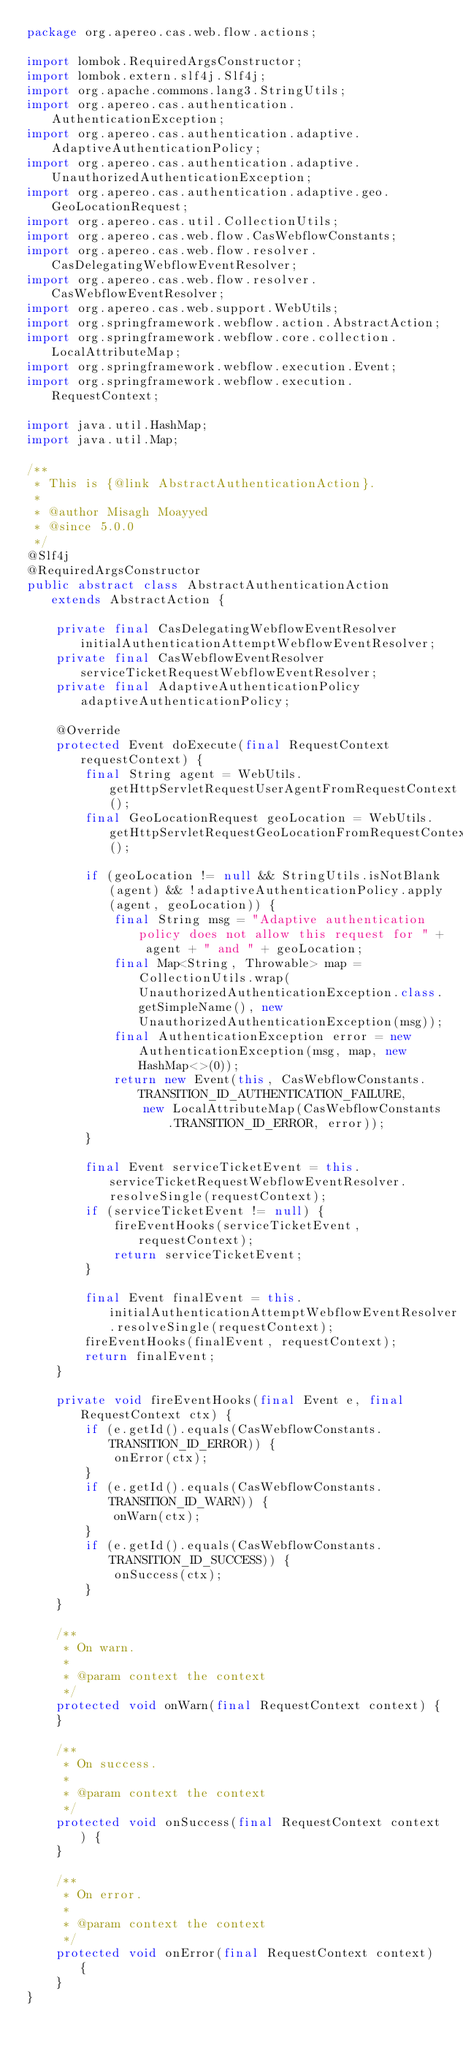Convert code to text. <code><loc_0><loc_0><loc_500><loc_500><_Java_>package org.apereo.cas.web.flow.actions;

import lombok.RequiredArgsConstructor;
import lombok.extern.slf4j.Slf4j;
import org.apache.commons.lang3.StringUtils;
import org.apereo.cas.authentication.AuthenticationException;
import org.apereo.cas.authentication.adaptive.AdaptiveAuthenticationPolicy;
import org.apereo.cas.authentication.adaptive.UnauthorizedAuthenticationException;
import org.apereo.cas.authentication.adaptive.geo.GeoLocationRequest;
import org.apereo.cas.util.CollectionUtils;
import org.apereo.cas.web.flow.CasWebflowConstants;
import org.apereo.cas.web.flow.resolver.CasDelegatingWebflowEventResolver;
import org.apereo.cas.web.flow.resolver.CasWebflowEventResolver;
import org.apereo.cas.web.support.WebUtils;
import org.springframework.webflow.action.AbstractAction;
import org.springframework.webflow.core.collection.LocalAttributeMap;
import org.springframework.webflow.execution.Event;
import org.springframework.webflow.execution.RequestContext;

import java.util.HashMap;
import java.util.Map;

/**
 * This is {@link AbstractAuthenticationAction}.
 *
 * @author Misagh Moayyed
 * @since 5.0.0
 */
@Slf4j
@RequiredArgsConstructor
public abstract class AbstractAuthenticationAction extends AbstractAction {

    private final CasDelegatingWebflowEventResolver initialAuthenticationAttemptWebflowEventResolver;
    private final CasWebflowEventResolver serviceTicketRequestWebflowEventResolver;
    private final AdaptiveAuthenticationPolicy adaptiveAuthenticationPolicy;

    @Override
    protected Event doExecute(final RequestContext requestContext) {
        final String agent = WebUtils.getHttpServletRequestUserAgentFromRequestContext();
        final GeoLocationRequest geoLocation = WebUtils.getHttpServletRequestGeoLocationFromRequestContext();

        if (geoLocation != null && StringUtils.isNotBlank(agent) && !adaptiveAuthenticationPolicy.apply(agent, geoLocation)) {
            final String msg = "Adaptive authentication policy does not allow this request for " + agent + " and " + geoLocation;
            final Map<String, Throwable> map = CollectionUtils.wrap(UnauthorizedAuthenticationException.class.getSimpleName(), new UnauthorizedAuthenticationException(msg));
            final AuthenticationException error = new AuthenticationException(msg, map, new HashMap<>(0));
            return new Event(this, CasWebflowConstants.TRANSITION_ID_AUTHENTICATION_FAILURE,
                new LocalAttributeMap(CasWebflowConstants.TRANSITION_ID_ERROR, error));
        }

        final Event serviceTicketEvent = this.serviceTicketRequestWebflowEventResolver.resolveSingle(requestContext);
        if (serviceTicketEvent != null) {
            fireEventHooks(serviceTicketEvent, requestContext);
            return serviceTicketEvent;
        }

        final Event finalEvent = this.initialAuthenticationAttemptWebflowEventResolver.resolveSingle(requestContext);
        fireEventHooks(finalEvent, requestContext);
        return finalEvent;
    }

    private void fireEventHooks(final Event e, final RequestContext ctx) {
        if (e.getId().equals(CasWebflowConstants.TRANSITION_ID_ERROR)) {
            onError(ctx);
        }
        if (e.getId().equals(CasWebflowConstants.TRANSITION_ID_WARN)) {
            onWarn(ctx);
        }
        if (e.getId().equals(CasWebflowConstants.TRANSITION_ID_SUCCESS)) {
            onSuccess(ctx);
        }
    }

    /**
     * On warn.
     *
     * @param context the context
     */
    protected void onWarn(final RequestContext context) {
    }

    /**
     * On success.
     *
     * @param context the context
     */
    protected void onSuccess(final RequestContext context) {
    }

    /**
     * On error.
     *
     * @param context the context
     */
    protected void onError(final RequestContext context) {
    }
}
</code> 